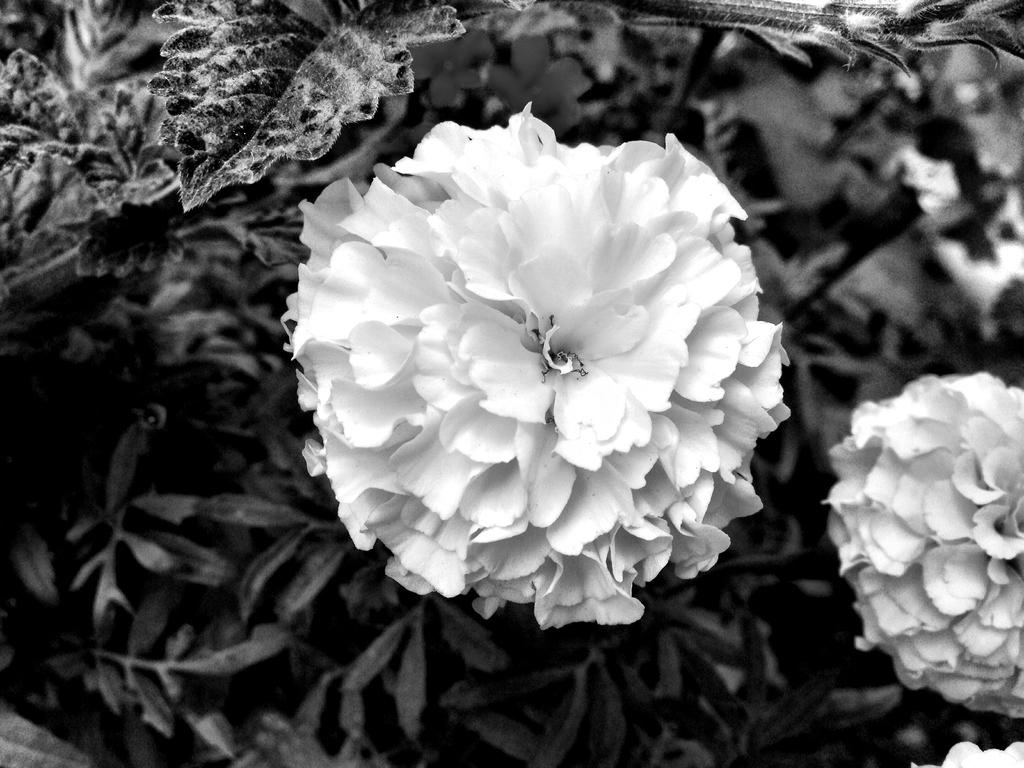What type of plants can be seen in the image? There are flowers and leaves in the image. Can you describe the appearance of the flowers? Unfortunately, the specific appearance of the flowers cannot be determined from the provided facts. What else is present in the image besides the flowers and leaves? No additional information is provided about other elements in the image. What type of support can be seen in the image? There is no information provided about any support in the image. What color is the button in the image? There is no button present in the image. 